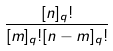<formula> <loc_0><loc_0><loc_500><loc_500>\frac { [ n ] _ { q } ! } { [ m ] _ { q } ! [ n - m ] _ { q } ! }</formula> 